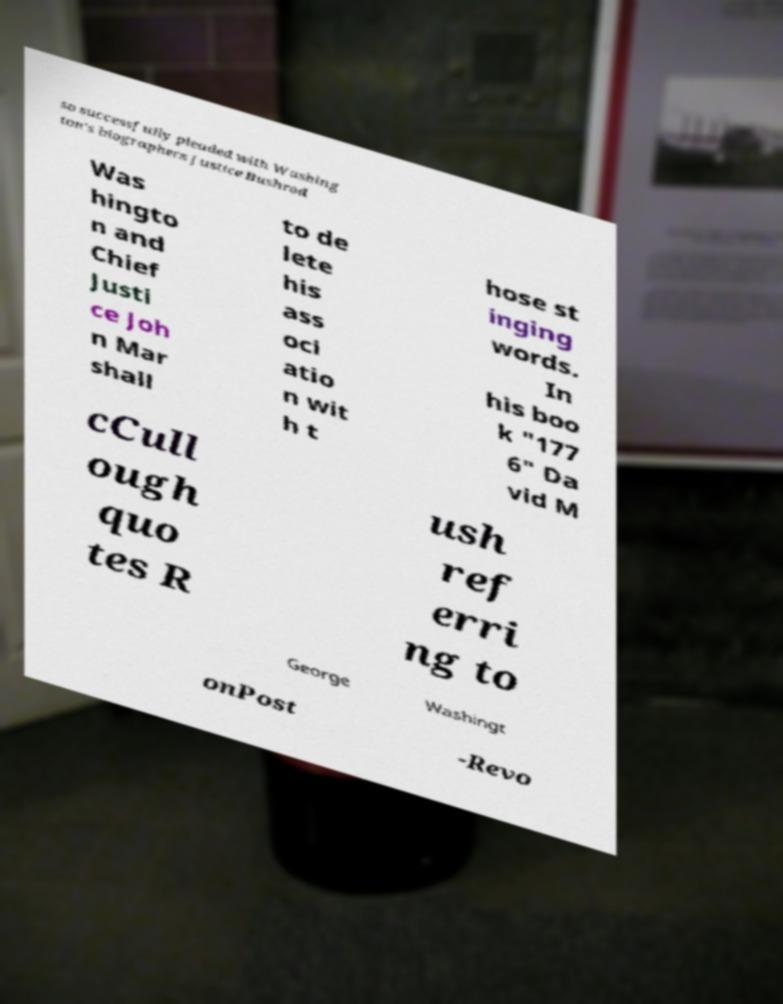I need the written content from this picture converted into text. Can you do that? so successfully pleaded with Washing ton's biographers Justice Bushrod Was hingto n and Chief Justi ce Joh n Mar shall to de lete his ass oci atio n wit h t hose st inging words. In his boo k "177 6" Da vid M cCull ough quo tes R ush ref erri ng to George Washingt onPost -Revo 